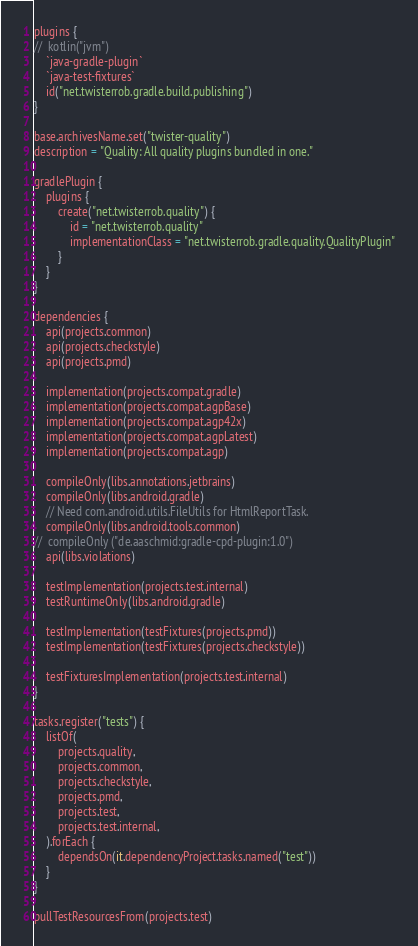Convert code to text. <code><loc_0><loc_0><loc_500><loc_500><_Kotlin_>plugins {
//	kotlin("jvm")
	`java-gradle-plugin`
	`java-test-fixtures`
	id("net.twisterrob.gradle.build.publishing")
}

base.archivesName.set("twister-quality")
description = "Quality: All quality plugins bundled in one."

gradlePlugin {
	plugins {
		create("net.twisterrob.quality") {
			id = "net.twisterrob.quality"
			implementationClass = "net.twisterrob.gradle.quality.QualityPlugin"
		}
	}
}

dependencies {
	api(projects.common)
	api(projects.checkstyle)
	api(projects.pmd)

	implementation(projects.compat.gradle)
	implementation(projects.compat.agpBase)
	implementation(projects.compat.agp42x)
	implementation(projects.compat.agpLatest)
	implementation(projects.compat.agp)

	compileOnly(libs.annotations.jetbrains)
	compileOnly(libs.android.gradle)
	// Need com.android.utils.FileUtils for HtmlReportTask.
	compileOnly(libs.android.tools.common)
//	compileOnly ("de.aaschmid:gradle-cpd-plugin:1.0")
	api(libs.violations)

	testImplementation(projects.test.internal)
	testRuntimeOnly(libs.android.gradle)

	testImplementation(testFixtures(projects.pmd))
	testImplementation(testFixtures(projects.checkstyle))

	testFixturesImplementation(projects.test.internal)
}

tasks.register("tests") {
	listOf(
		projects.quality,
		projects.common,
		projects.checkstyle,
		projects.pmd,
		projects.test,
		projects.test.internal,
	).forEach {
		dependsOn(it.dependencyProject.tasks.named("test"))
	}
}

pullTestResourcesFrom(projects.test)
</code> 